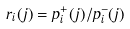<formula> <loc_0><loc_0><loc_500><loc_500>r _ { i } ( j ) = p ^ { + } _ { i } ( j ) / p ^ { - } _ { i } ( j )</formula> 